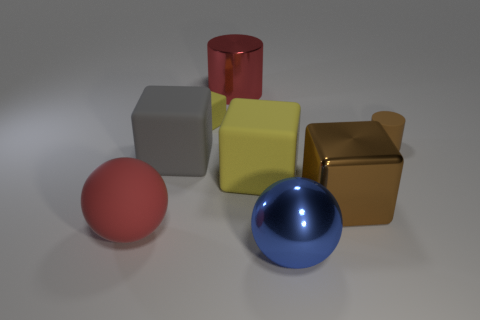Subtract all yellow cubes. How many were subtracted if there are1yellow cubes left? 1 Add 2 tiny yellow matte balls. How many objects exist? 10 Subtract all rubber cubes. How many cubes are left? 1 Subtract all spheres. How many objects are left? 6 Subtract 1 cylinders. How many cylinders are left? 1 Subtract all green spheres. How many green blocks are left? 0 Subtract all purple blocks. Subtract all brown blocks. How many objects are left? 7 Add 3 large metallic objects. How many large metallic objects are left? 6 Add 2 tiny brown rubber cylinders. How many tiny brown rubber cylinders exist? 3 Subtract all yellow cubes. How many cubes are left? 2 